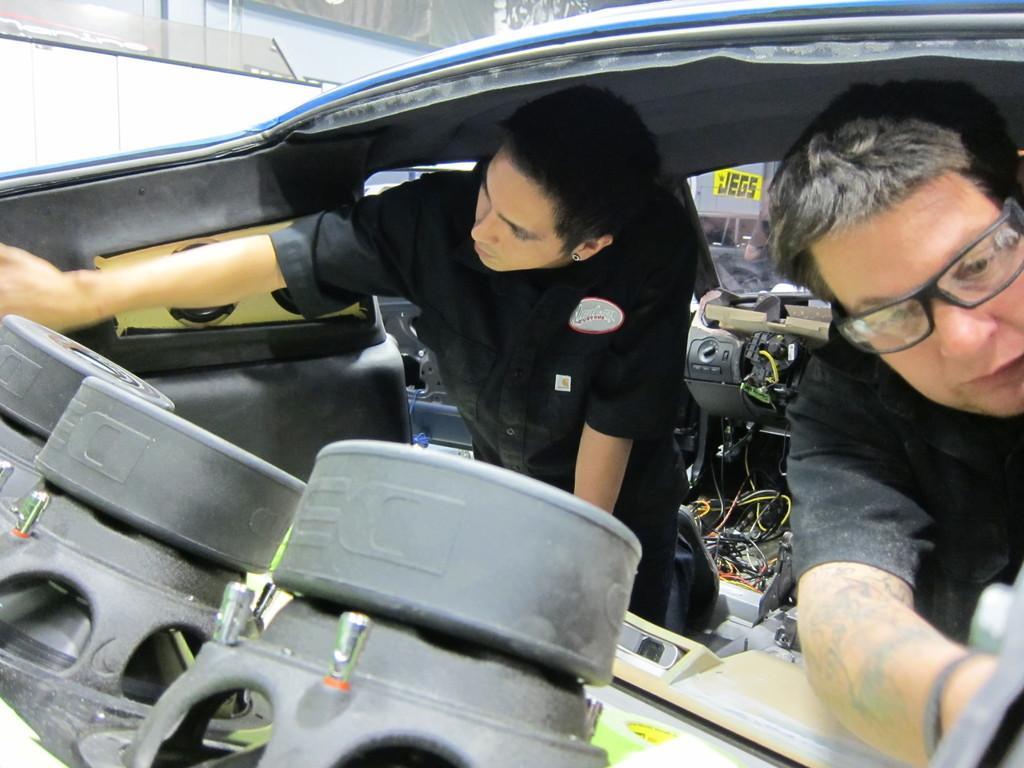Please provide a concise description of this image. At the bottom of the picture, we see the black color objects. In the middle, we see two men who are wearing the black dress might be repairing the car. Behind them, we see the cables and the inner parts of the car. In the background, we see a building and a board in yellow color with some text written on it. In the left top, we see the glass windows and a grey wall. 